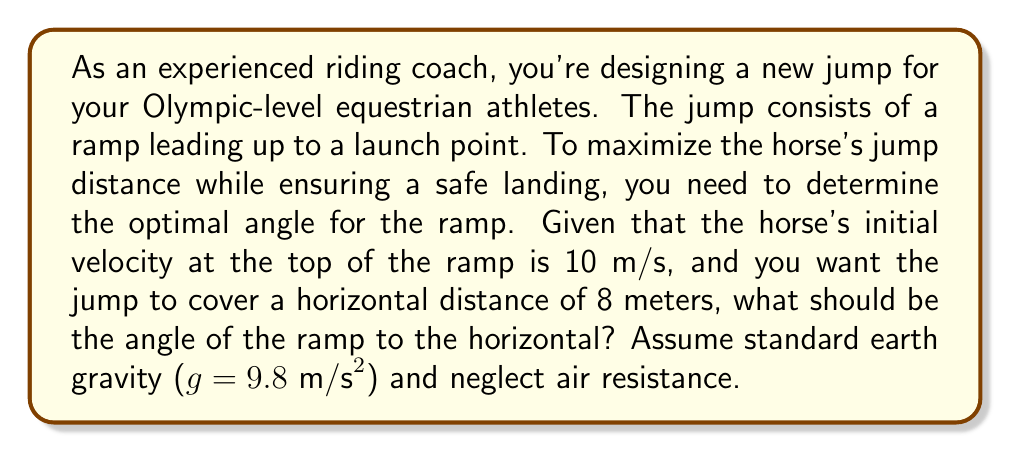Provide a solution to this math problem. To solve this problem, we'll use the principles of projectile motion and trigonometry. Let's break it down step by step:

1) In projectile motion, the horizontal distance (d) covered is given by:
   
   $d = v_0 \cos(\theta) t$

   Where $v_0$ is the initial velocity, $\theta$ is the launch angle, and $t$ is the time of flight.

2) The time of flight can be calculated using the vertical component of motion:
   
   $y = v_0 \sin(\theta) t - \frac{1}{2}gt^2$

   At the landing point, y = 0, so:

   $0 = v_0 \sin(\theta) t - \frac{1}{2}gt^2$

3) Solving for t:
   
   $t = \frac{2v_0 \sin(\theta)}{g}$

4) Substituting this into the equation for d:

   $d = v_0 \cos(\theta) \cdot \frac{2v_0 \sin(\theta)}{g}$

5) Simplifying:

   $d = \frac{2v_0^2 \sin(\theta) \cos(\theta)}{g}$

6) Using the trigonometric identity $\sin(2\theta) = 2\sin(\theta)\cos(\theta)$:

   $d = \frac{v_0^2 \sin(2\theta)}{g}$

7) Now, we can solve for $\theta$:

   $\sin(2\theta) = \frac{dg}{v_0^2}$

8) Substituting our known values ($d = 8$ m, $g = 9.8 \text{ m/s}^2$, $v_0 = 10 \text{ m/s}$):

   $\sin(2\theta) = \frac{8 \cdot 9.8}{10^2} = 0.784$

9) Taking the inverse sine:

   $2\theta = \arcsin(0.784) = 51.68°$

10) Finally, solving for $\theta$:

    $\theta = 25.84°$

Therefore, the optimal angle for the ramp is approximately 25.84 degrees to the horizontal.
Answer: $25.84°$ 